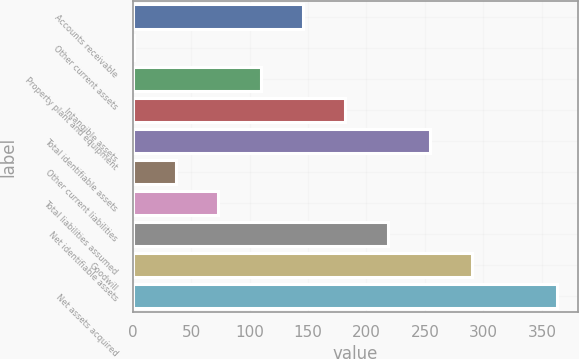Convert chart. <chart><loc_0><loc_0><loc_500><loc_500><bar_chart><fcel>Accounts receivable<fcel>Other current assets<fcel>Property plant and equipment<fcel>Intangible assets<fcel>Total identifiable assets<fcel>Other current liabilities<fcel>Total liabilities assumed<fcel>Net identifiable assets<fcel>Goodwill<fcel>Net assets acquired<nl><fcel>145.8<fcel>1<fcel>109.6<fcel>182<fcel>254.4<fcel>37.2<fcel>73.4<fcel>218.2<fcel>290.6<fcel>363<nl></chart> 